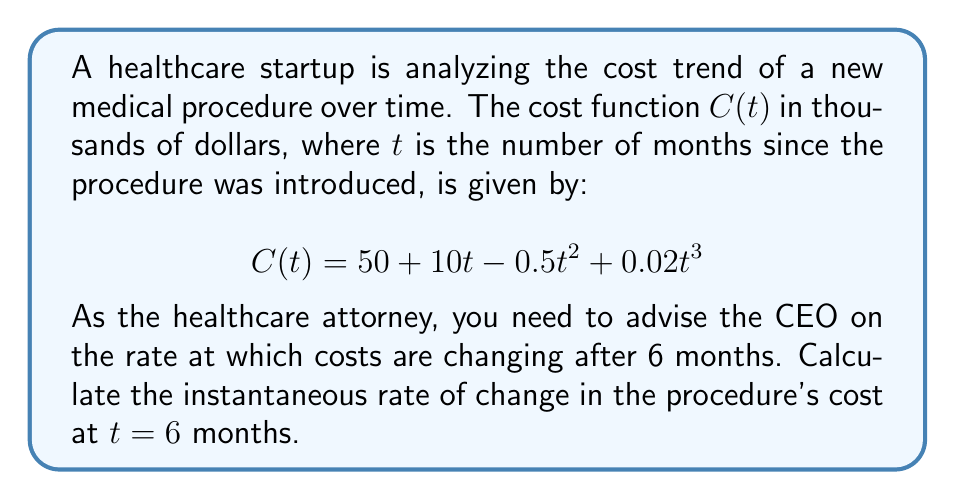What is the answer to this math problem? To find the instantaneous rate of change at t = 6 months, we need to calculate the derivative of the cost function C(t) and then evaluate it at t = 6.

Step 1: Find the derivative of C(t)
$$\frac{d}{dt}C(t) = \frac{d}{dt}(50 + 10t - 0.5t^2 + 0.02t^3)$$
$$C'(t) = 10 - t + 0.06t^2$$

Step 2: Evaluate C'(t) at t = 6
$$C'(6) = 10 - 6 + 0.06(6^2)$$
$$C'(6) = 10 - 6 + 0.06(36)$$
$$C'(6) = 10 - 6 + 2.16$$
$$C'(6) = 6.16$$

The instantaneous rate of change at t = 6 months is 6.16 thousand dollars per month.

Step 3: Interpret the result
This means that after 6 months, the cost of the medical procedure is increasing at a rate of $6,160 per month. As the healthcare attorney, you should advise the CEO that costs are still rising, but at a decreasing rate compared to the initial $10,000 per month increase (from the linear term in the original function).
Answer: $6,160 per month 